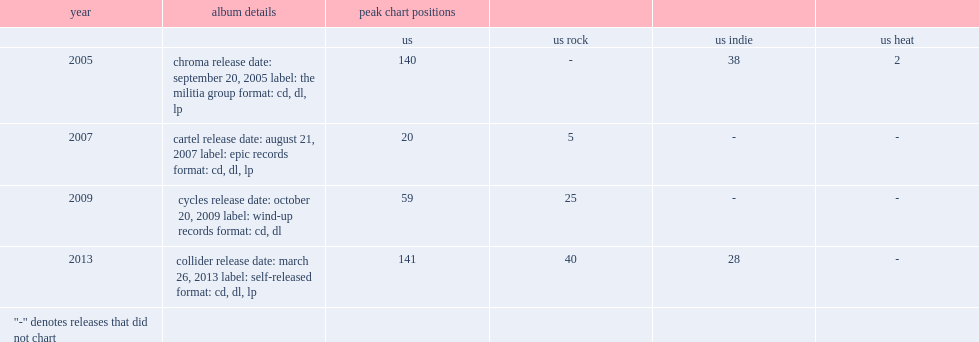What was the peak chart position on the billboard 200 chart of collider? 141.0. 